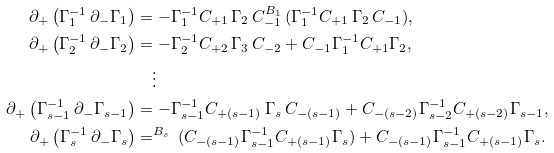<formula> <loc_0><loc_0><loc_500><loc_500>\partial _ { + } \left ( \Gamma _ { 1 } ^ { - 1 } \, \partial _ { - } \Gamma _ { 1 } \right ) & = - \Gamma _ { 1 } ^ { - 1 } C _ { + 1 } \, \Gamma _ { 2 } \, C _ { - 1 } ^ { B _ { 1 } \, } ( \Gamma _ { 1 } ^ { - 1 } C _ { + 1 } \, \Gamma _ { 2 } \, C _ { - 1 } ) , \\ \partial _ { + } \left ( \Gamma _ { 2 } ^ { - 1 } \, \partial _ { - } \Gamma _ { 2 } \right ) & = - \Gamma _ { 2 } ^ { - 1 } C _ { + 2 } \, \Gamma _ { 3 } \, C _ { - 2 } + C _ { - 1 } \Gamma _ { 1 } ^ { - 1 } C _ { + 1 } \Gamma _ { 2 } , \\ & \quad \vdots \\ \partial _ { + } \left ( \Gamma _ { s - 1 } ^ { - 1 } \, \partial _ { - } \Gamma _ { s - 1 } \right ) & = - \Gamma _ { s - 1 } ^ { - 1 } C _ { + ( s - 1 ) } \, \Gamma _ { s } \, C _ { - ( s - 1 ) } + C _ { - ( s - 2 ) } \Gamma _ { s - 2 } ^ { - 1 } C _ { + ( s - 2 ) } \Gamma _ { s - 1 } , \\ \partial _ { + } \left ( \Gamma _ { s } ^ { - 1 } \, \partial _ { - } \Gamma _ { s } \right ) & = ^ { B _ { s } \, } ( C _ { - ( s - 1 ) } \Gamma _ { s - 1 } ^ { - 1 } C _ { + ( s - 1 ) } \Gamma _ { s } ) + C _ { - ( s - 1 ) } \Gamma _ { s - 1 } ^ { - 1 } C _ { + ( s - 1 ) } \Gamma _ { s } .</formula> 